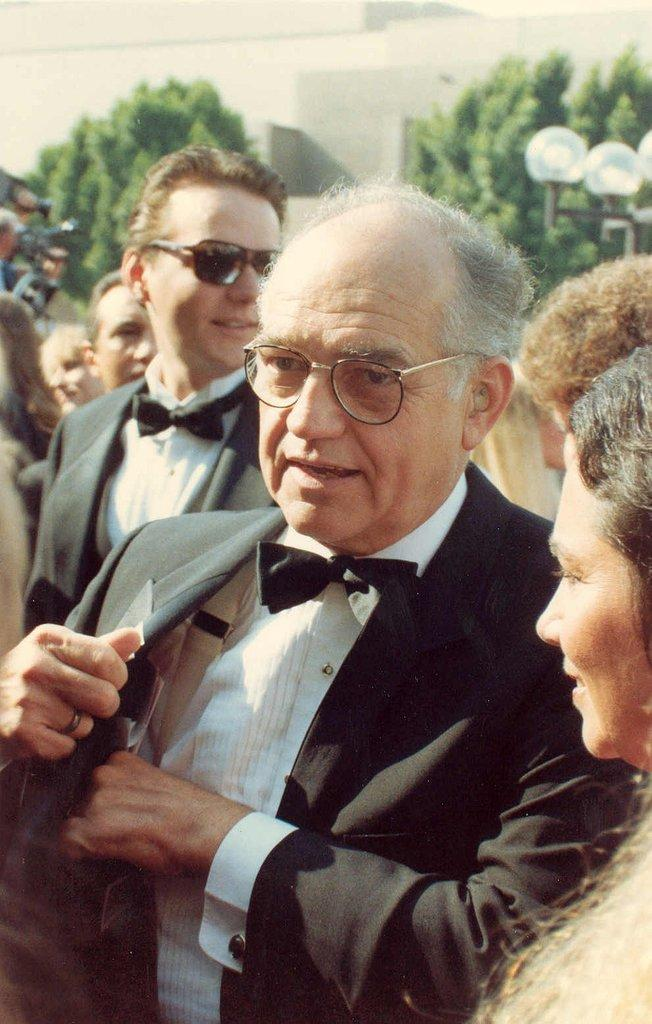What can be seen in the image? There are people standing in the image. Can you describe the people in the image? Some of the people are wearing spectacles. What else is visible in the image besides the people? There are trees, poles, lights, and a wall visible in the image. What type of committee meeting is taking place in the image? There is no committee meeting present in the image; it only shows people standing with other objects and elements. Can you describe the bedroom furniture in the image? There is no bedroom furniture present in the image; it features people, trees, poles, lights, and a wall. 